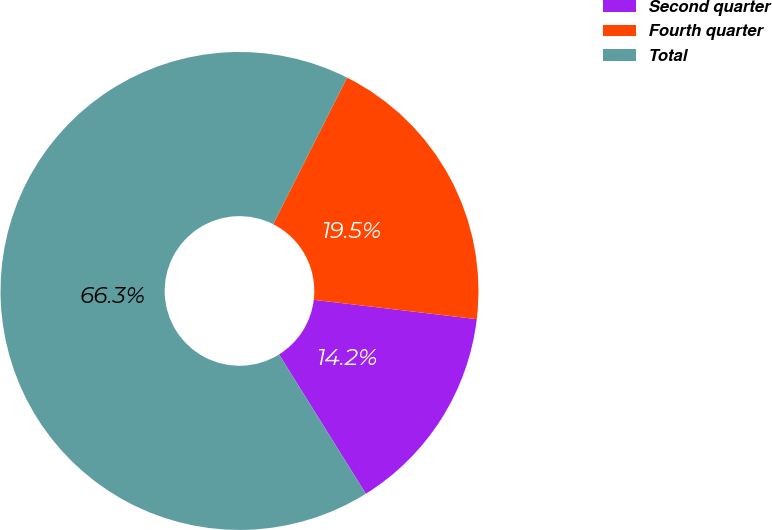Convert chart. <chart><loc_0><loc_0><loc_500><loc_500><pie_chart><fcel>Second quarter<fcel>Fourth quarter<fcel>Total<nl><fcel>14.25%<fcel>19.45%<fcel>66.3%<nl></chart> 